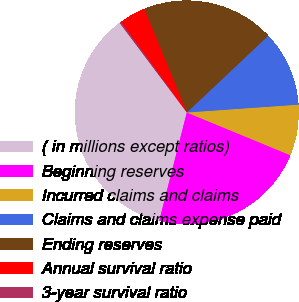Convert chart to OTSL. <chart><loc_0><loc_0><loc_500><loc_500><pie_chart><fcel>( in millions except ratios)<fcel>Beginning reserves<fcel>Incurred claims and claims<fcel>Claims and claims expense paid<fcel>Ending reserves<fcel>Annual survival ratio<fcel>3-year survival ratio<nl><fcel>35.79%<fcel>22.74%<fcel>7.35%<fcel>10.91%<fcel>19.18%<fcel>3.8%<fcel>0.24%<nl></chart> 